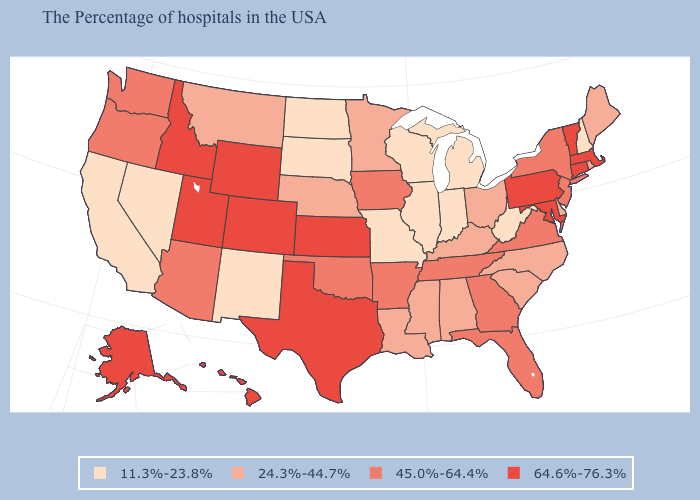What is the lowest value in the USA?
Concise answer only. 11.3%-23.8%. What is the lowest value in the USA?
Concise answer only. 11.3%-23.8%. Does Wisconsin have the lowest value in the USA?
Keep it brief. Yes. What is the value of Mississippi?
Give a very brief answer. 24.3%-44.7%. What is the value of Michigan?
Concise answer only. 11.3%-23.8%. Does Delaware have a higher value than Rhode Island?
Write a very short answer. No. What is the highest value in the USA?
Concise answer only. 64.6%-76.3%. What is the value of Rhode Island?
Be succinct. 24.3%-44.7%. Name the states that have a value in the range 24.3%-44.7%?
Concise answer only. Maine, Rhode Island, Delaware, North Carolina, South Carolina, Ohio, Kentucky, Alabama, Mississippi, Louisiana, Minnesota, Nebraska, Montana. Among the states that border Illinois , which have the lowest value?
Short answer required. Indiana, Wisconsin, Missouri. Name the states that have a value in the range 64.6%-76.3%?
Quick response, please. Massachusetts, Vermont, Connecticut, Maryland, Pennsylvania, Kansas, Texas, Wyoming, Colorado, Utah, Idaho, Alaska, Hawaii. What is the value of Ohio?
Short answer required. 24.3%-44.7%. Name the states that have a value in the range 64.6%-76.3%?
Answer briefly. Massachusetts, Vermont, Connecticut, Maryland, Pennsylvania, Kansas, Texas, Wyoming, Colorado, Utah, Idaho, Alaska, Hawaii. What is the lowest value in the USA?
Quick response, please. 11.3%-23.8%. Which states have the highest value in the USA?
Write a very short answer. Massachusetts, Vermont, Connecticut, Maryland, Pennsylvania, Kansas, Texas, Wyoming, Colorado, Utah, Idaho, Alaska, Hawaii. 